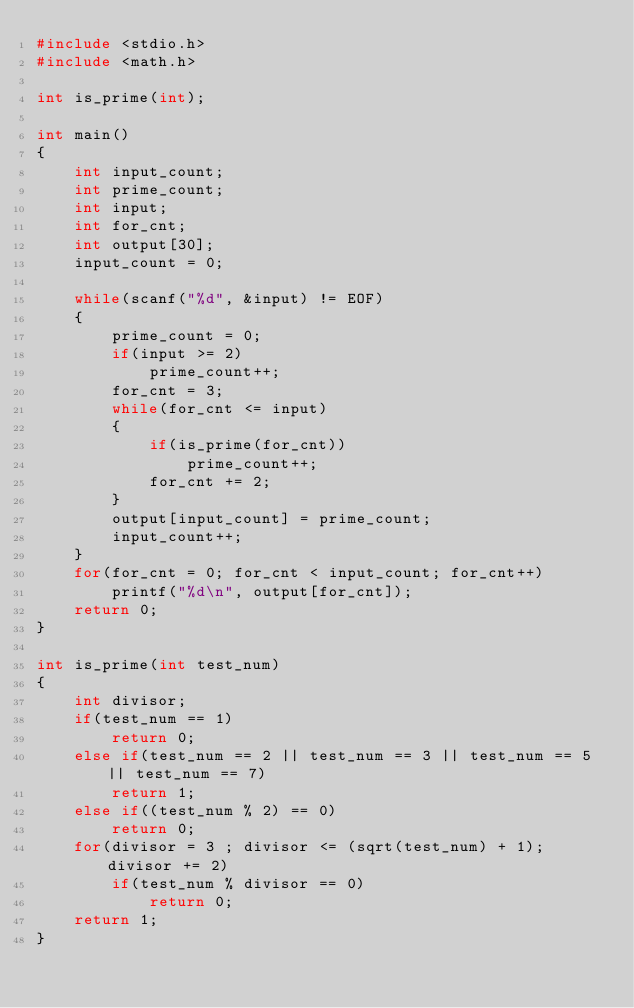Convert code to text. <code><loc_0><loc_0><loc_500><loc_500><_C_>#include <stdio.h>
#include <math.h>

int is_prime(int);

int main()
{
	int input_count;
	int prime_count;
	int input;
	int for_cnt;
	int output[30];
	input_count = 0;
	
	while(scanf("%d", &input) != EOF)
	{
		prime_count = 0;
		if(input >= 2)
			prime_count++;
		for_cnt = 3;
		while(for_cnt <= input)
		{
			if(is_prime(for_cnt))
				prime_count++;
			for_cnt += 2;
		}
		output[input_count] = prime_count;
		input_count++;
	}
	for(for_cnt = 0; for_cnt < input_count; for_cnt++)
		printf("%d\n", output[for_cnt]);
	return 0;
}

int is_prime(int test_num)
{
	int divisor;
	if(test_num == 1)
		return 0;
	else if(test_num == 2 || test_num == 3 || test_num == 5 || test_num == 7)
		return 1;
	else if((test_num % 2) == 0)
		return 0;
	for(divisor = 3 ; divisor <= (sqrt(test_num) + 1); divisor += 2)
		if(test_num % divisor == 0)
			return 0;
	return 1;
}</code> 